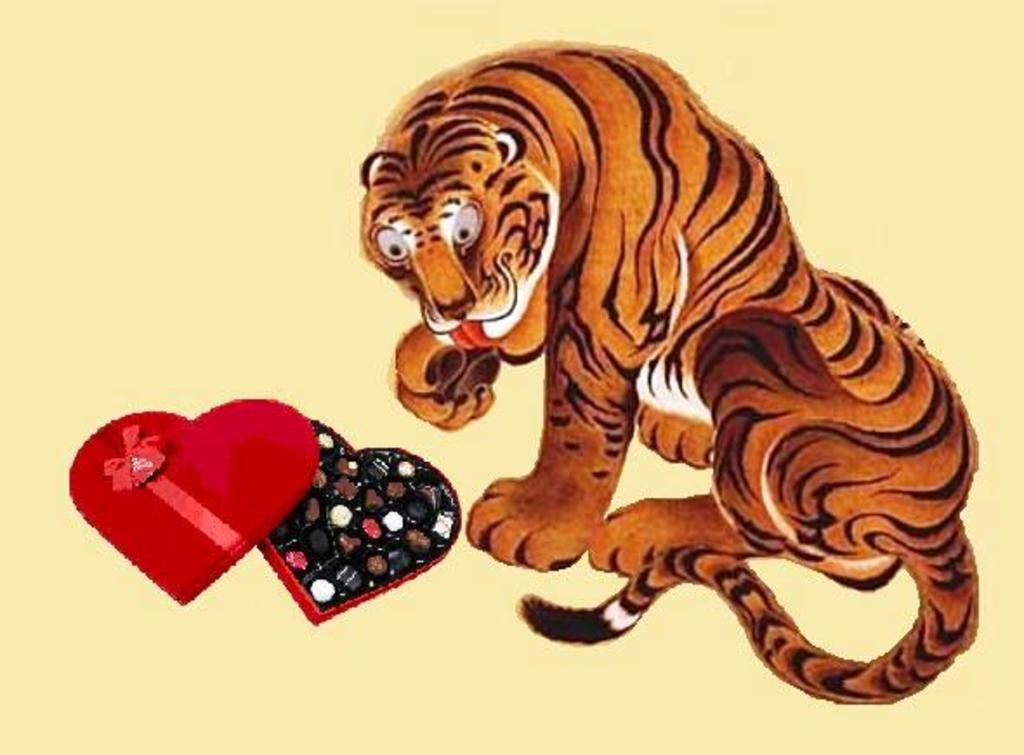What is depicted in the sketch in the image? There is a sketch of a tiger in the image. What object is placed in front of the tiger in the image? There is a chocolate box in front of the tiger in the image. What country is the tiger from in the image? The image does not provide information about the tiger's country of origin. Can you describe the tiger's jump in the image? The image does not depict the tiger jumping; it is a static sketch. 